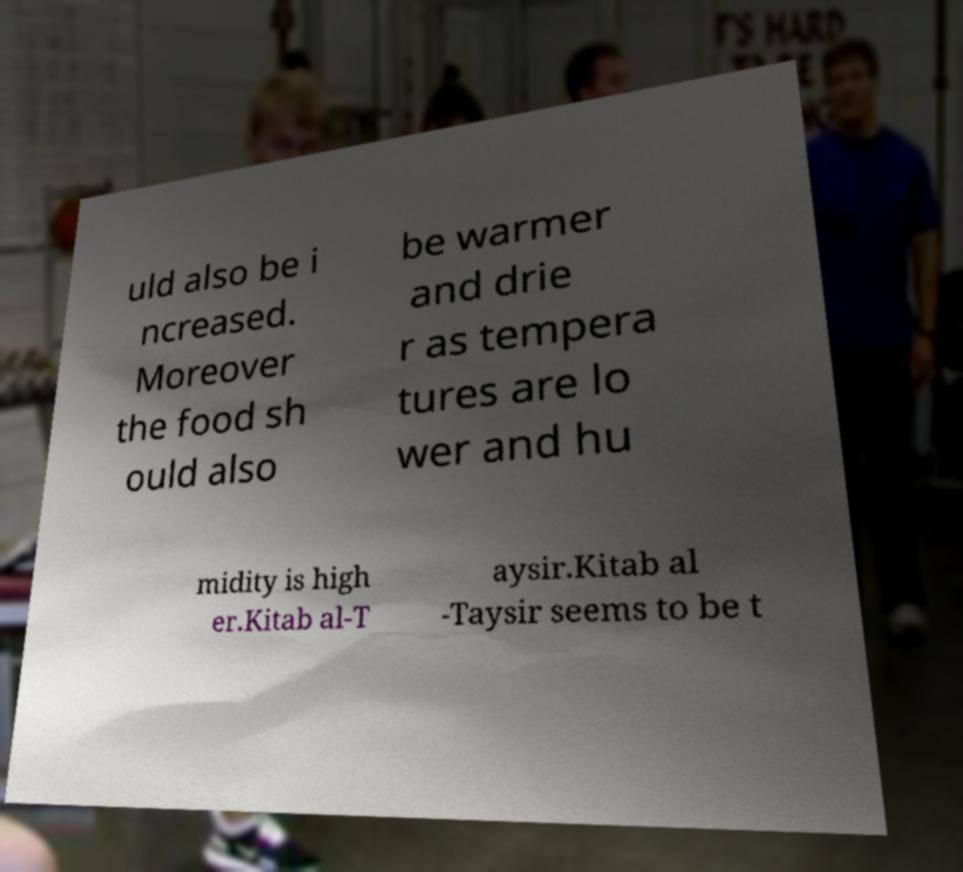Can you accurately transcribe the text from the provided image for me? uld also be i ncreased. Moreover the food sh ould also be warmer and drie r as tempera tures are lo wer and hu midity is high er.Kitab al-T aysir.Kitab al -Taysir seems to be t 